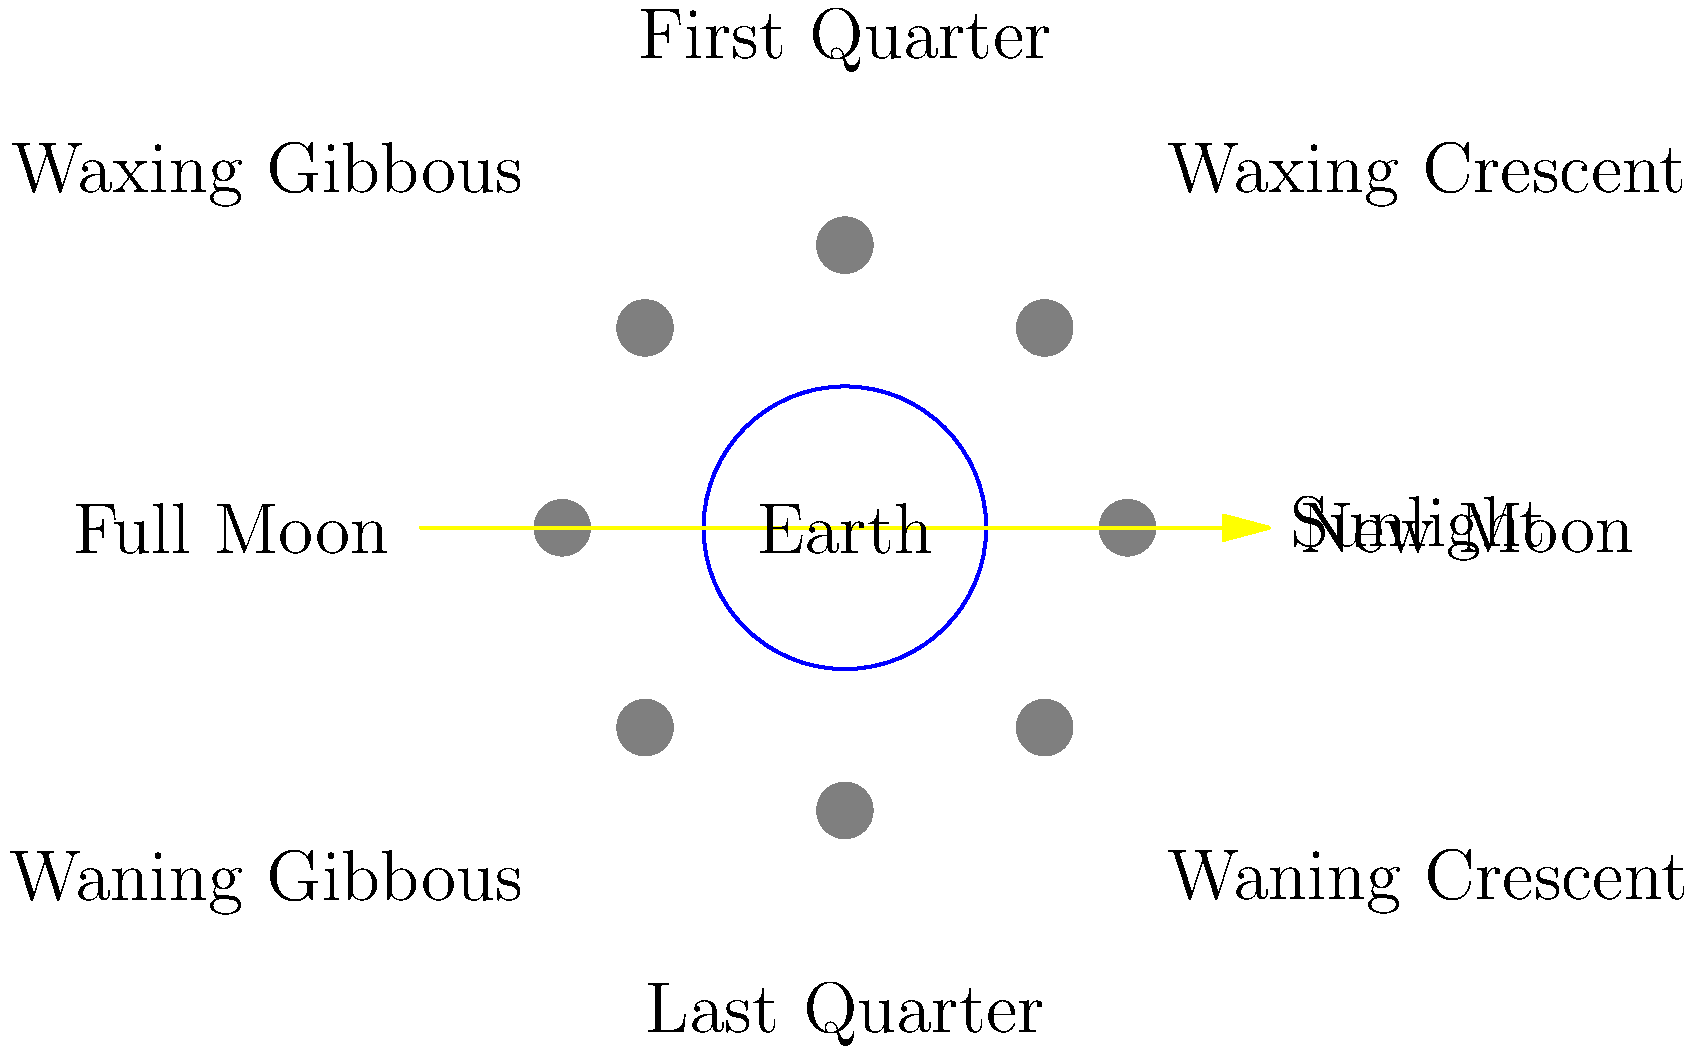As an amateur astronomer, you're studying the relationship between moon phases and tidal forces. Based on the diagram, during which two moon phases would you expect the highest tides (spring tides) to occur on Earth, and how might this phenomenon relate to potential cosmic influences on cryptographic systems? To answer this question, let's break it down step-by-step:

1. Moon phases and tidal forces:
   - Tides are primarily caused by the gravitational pull of the moon on Earth's oceans.
   - The sun also contributes to tides, but to a lesser extent.

2. Spring tides:
   - Spring tides occur when the gravitational forces of the moon and sun align.
   - This happens when the Earth, moon, and sun are in a straight line.

3. Examining the diagram:
   - The diagram shows the moon's phases as it orbits Earth.
   - The sun's light is coming from the right side of the diagram.

4. Identifying spring tide phases:
   - New Moon: The moon is between Earth and the sun, creating alignment.
   - Full Moon: Earth is between the moon and the sun, also creating alignment.

5. Highest tides:
   - Spring tides occur during New Moon and Full Moon phases.
   - These are when the tidal forces of the moon and sun combine.

6. Relation to cryptographic systems:
   - While there's no direct link between tides and cryptography, this phenomenon demonstrates:
     a) The importance of cyclic patterns in nature.
     b) The influence of cosmic bodies on Earth's systems.
   - In cryptography, we often use cyclic patterns and natural phenomena as sources of entropy or for generating random numbers.
   - Understanding these cosmic cycles could potentially inspire new approaches to cryptographic key generation or encryption algorithms.
Answer: New Moon and Full Moon; cosmic cycles as potential entropy sources for cryptographic systems. 